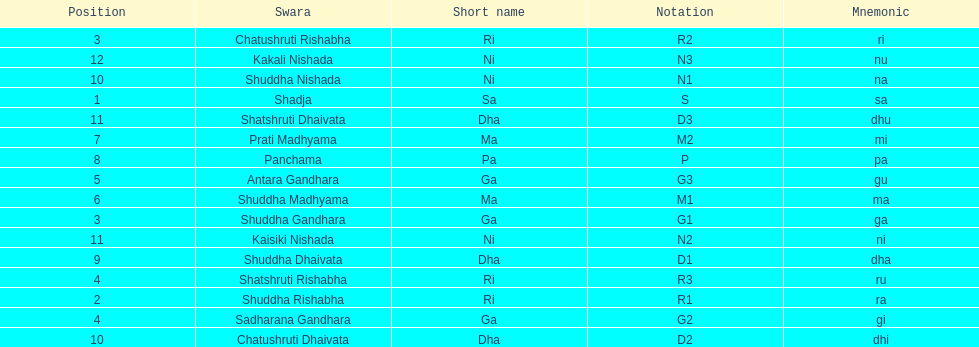Which swara holds the last position? Kakali Nishada. 